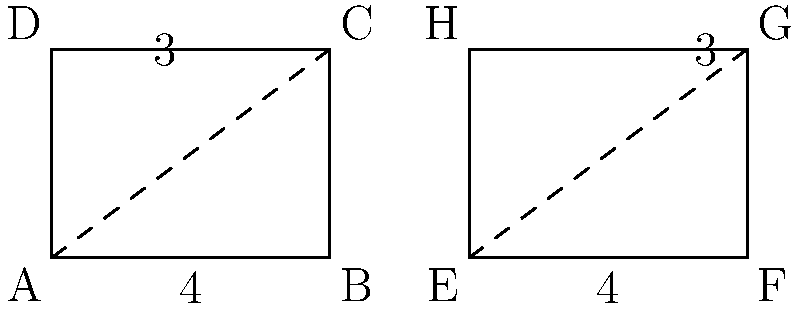During a naval operation, two identical rectangular metal plates are used to reinforce ship hulls. The dimensions of each plate are 4 units by 3 units. If these plates are congruent, what is the total area that can be reinforced using both plates? To solve this problem, we need to follow these steps:

1. Recognize that the two rectangles are congruent, meaning they have the same shape and size.

2. Calculate the area of one rectangular plate:
   $A = l \times w$, where $A$ is area, $l$ is length, and $w$ is width
   $A = 4 \times 3 = 12$ square units

3. Since we have two identical plates, we need to multiply the area of one plate by 2:
   Total Area $= 2 \times 12 = 24$ square units

Therefore, the total area that can be reinforced using both plates is 24 square units.
Answer: 24 square units 